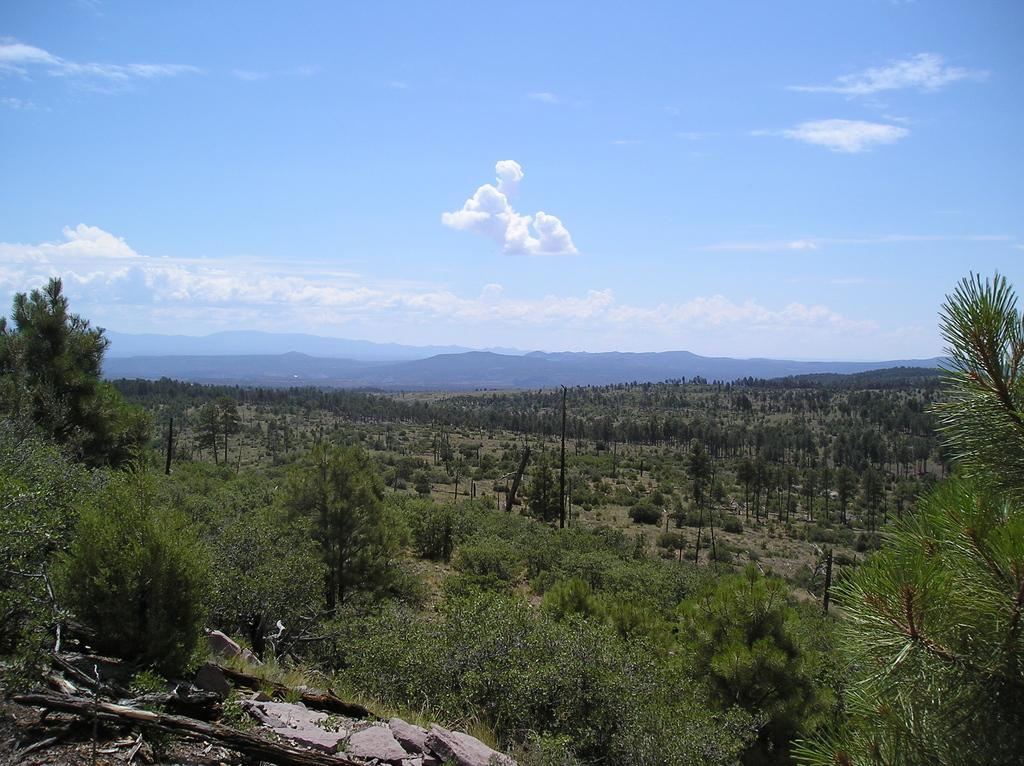Please provide a concise description of this image. In this picture we can see few trees, poles, hills and clouds. 